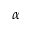Convert formula to latex. <formula><loc_0><loc_0><loc_500><loc_500>\alpha</formula> 